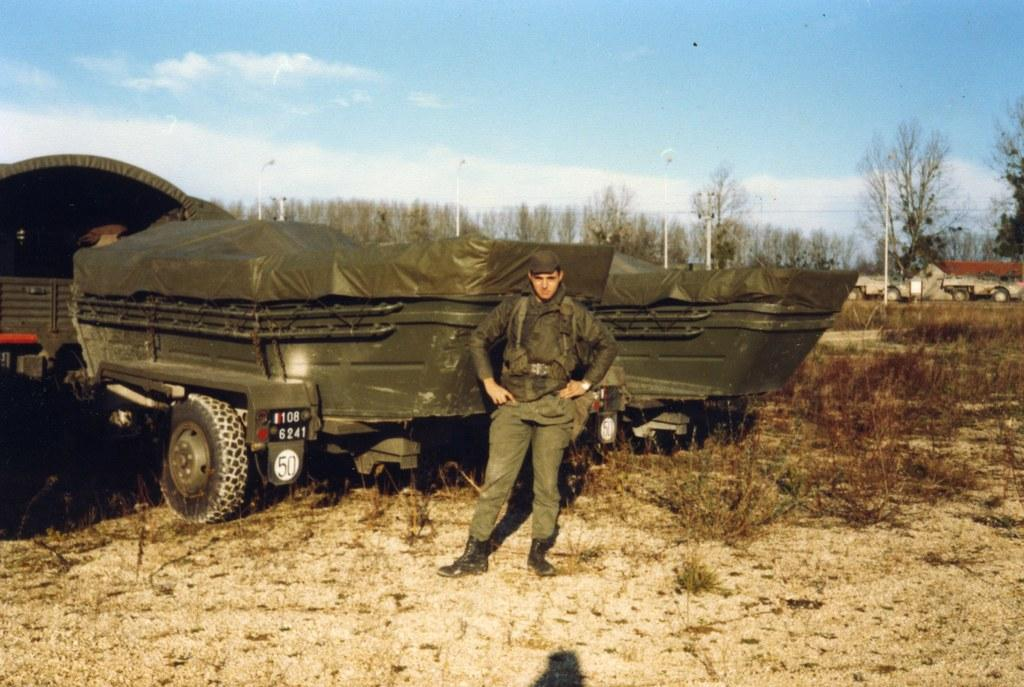What is the person in the image doing? The person is standing on the ground in the image. What else can be seen in the image besides the person? There are vehicles, trees, poles, lights, grass, a building, and the sky with clouds visible in the image. Can you describe the vehicles in the image? The provided facts do not specify the type or number of vehicles in the image. What type of vegetation is present in the image? There are trees and grass in the image. What is the background of the image? The sky with clouds is visible in the background of the image. How does the person in the image comb their hair? There is no information about the person's hair or any combing activity in the image. Is there a river visible in the image? No, there is no river present in the image. 